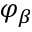<formula> <loc_0><loc_0><loc_500><loc_500>\varphi _ { \beta }</formula> 